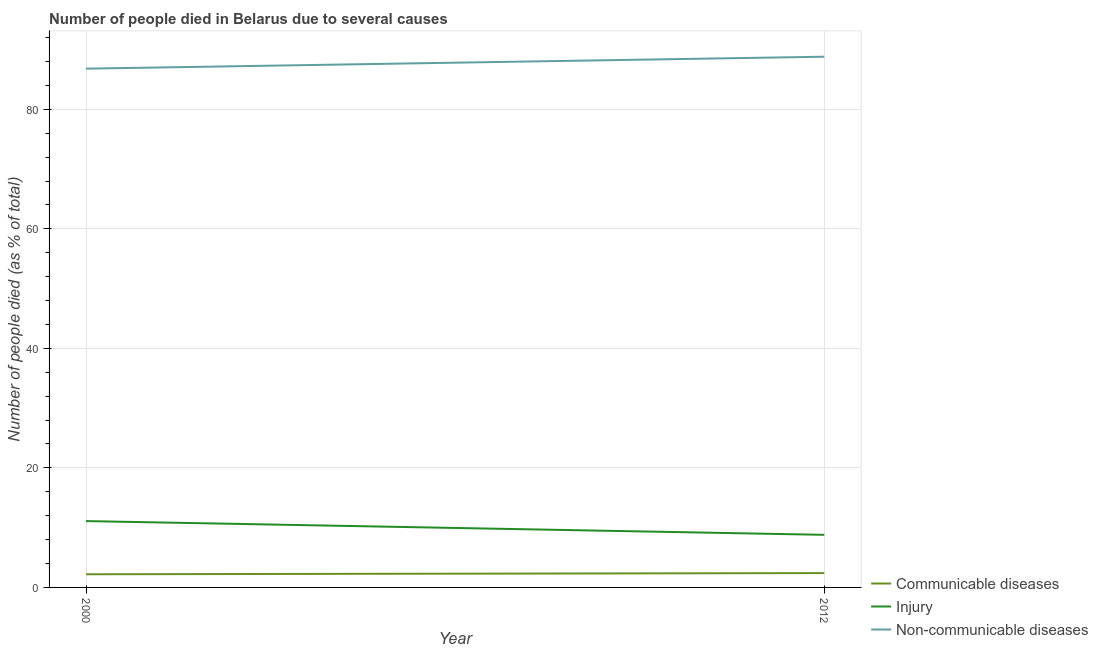How many different coloured lines are there?
Keep it short and to the point. 3. Is the number of lines equal to the number of legend labels?
Keep it short and to the point. Yes. What is the number of people who dies of non-communicable diseases in 2012?
Your answer should be very brief. 88.8. Across all years, what is the minimum number of people who dies of non-communicable diseases?
Provide a short and direct response. 86.8. In which year was the number of people who died of communicable diseases minimum?
Your answer should be compact. 2000. What is the difference between the number of people who died of injury in 2000 and that in 2012?
Your answer should be compact. 2.3. What is the difference between the number of people who dies of non-communicable diseases in 2012 and the number of people who died of communicable diseases in 2000?
Keep it short and to the point. 86.6. What is the average number of people who dies of non-communicable diseases per year?
Offer a very short reply. 87.8. In the year 2012, what is the difference between the number of people who died of communicable diseases and number of people who dies of non-communicable diseases?
Your answer should be very brief. -86.4. In how many years, is the number of people who dies of non-communicable diseases greater than 20 %?
Offer a very short reply. 2. What is the ratio of the number of people who died of communicable diseases in 2000 to that in 2012?
Provide a succinct answer. 0.92. Is it the case that in every year, the sum of the number of people who died of communicable diseases and number of people who died of injury is greater than the number of people who dies of non-communicable diseases?
Your answer should be very brief. No. Is the number of people who dies of non-communicable diseases strictly less than the number of people who died of communicable diseases over the years?
Offer a terse response. No. Are the values on the major ticks of Y-axis written in scientific E-notation?
Your response must be concise. No. Does the graph contain any zero values?
Your answer should be very brief. No. Where does the legend appear in the graph?
Offer a terse response. Bottom right. How are the legend labels stacked?
Offer a very short reply. Vertical. What is the title of the graph?
Your answer should be very brief. Number of people died in Belarus due to several causes. Does "Ores and metals" appear as one of the legend labels in the graph?
Provide a short and direct response. No. What is the label or title of the Y-axis?
Keep it short and to the point. Number of people died (as % of total). What is the Number of people died (as % of total) in Communicable diseases in 2000?
Offer a very short reply. 2.2. What is the Number of people died (as % of total) of Non-communicable diseases in 2000?
Ensure brevity in your answer.  86.8. What is the Number of people died (as % of total) of Communicable diseases in 2012?
Your response must be concise. 2.4. What is the Number of people died (as % of total) of Injury in 2012?
Offer a very short reply. 8.8. What is the Number of people died (as % of total) of Non-communicable diseases in 2012?
Offer a very short reply. 88.8. Across all years, what is the maximum Number of people died (as % of total) in Injury?
Your response must be concise. 11.1. Across all years, what is the maximum Number of people died (as % of total) of Non-communicable diseases?
Provide a short and direct response. 88.8. Across all years, what is the minimum Number of people died (as % of total) in Communicable diseases?
Your answer should be compact. 2.2. Across all years, what is the minimum Number of people died (as % of total) in Injury?
Make the answer very short. 8.8. Across all years, what is the minimum Number of people died (as % of total) of Non-communicable diseases?
Offer a terse response. 86.8. What is the total Number of people died (as % of total) in Injury in the graph?
Your answer should be compact. 19.9. What is the total Number of people died (as % of total) in Non-communicable diseases in the graph?
Provide a short and direct response. 175.6. What is the difference between the Number of people died (as % of total) of Communicable diseases in 2000 and the Number of people died (as % of total) of Non-communicable diseases in 2012?
Provide a succinct answer. -86.6. What is the difference between the Number of people died (as % of total) of Injury in 2000 and the Number of people died (as % of total) of Non-communicable diseases in 2012?
Give a very brief answer. -77.7. What is the average Number of people died (as % of total) of Communicable diseases per year?
Your response must be concise. 2.3. What is the average Number of people died (as % of total) in Injury per year?
Your answer should be compact. 9.95. What is the average Number of people died (as % of total) of Non-communicable diseases per year?
Give a very brief answer. 87.8. In the year 2000, what is the difference between the Number of people died (as % of total) in Communicable diseases and Number of people died (as % of total) in Non-communicable diseases?
Make the answer very short. -84.6. In the year 2000, what is the difference between the Number of people died (as % of total) of Injury and Number of people died (as % of total) of Non-communicable diseases?
Keep it short and to the point. -75.7. In the year 2012, what is the difference between the Number of people died (as % of total) in Communicable diseases and Number of people died (as % of total) in Non-communicable diseases?
Your answer should be compact. -86.4. In the year 2012, what is the difference between the Number of people died (as % of total) of Injury and Number of people died (as % of total) of Non-communicable diseases?
Give a very brief answer. -80. What is the ratio of the Number of people died (as % of total) of Injury in 2000 to that in 2012?
Your answer should be compact. 1.26. What is the ratio of the Number of people died (as % of total) in Non-communicable diseases in 2000 to that in 2012?
Offer a very short reply. 0.98. What is the difference between the highest and the second highest Number of people died (as % of total) in Communicable diseases?
Provide a short and direct response. 0.2. What is the difference between the highest and the second highest Number of people died (as % of total) in Injury?
Your answer should be very brief. 2.3. What is the difference between the highest and the second highest Number of people died (as % of total) in Non-communicable diseases?
Your answer should be very brief. 2. What is the difference between the highest and the lowest Number of people died (as % of total) of Communicable diseases?
Keep it short and to the point. 0.2. What is the difference between the highest and the lowest Number of people died (as % of total) in Injury?
Give a very brief answer. 2.3. 